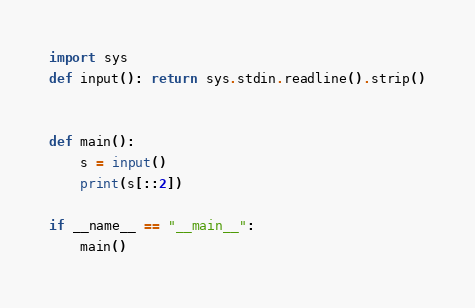<code> <loc_0><loc_0><loc_500><loc_500><_Python_>import sys
def input(): return sys.stdin.readline().strip()


def main():
    s = input()
    print(s[::2])

if __name__ == "__main__":
    main()
</code> 